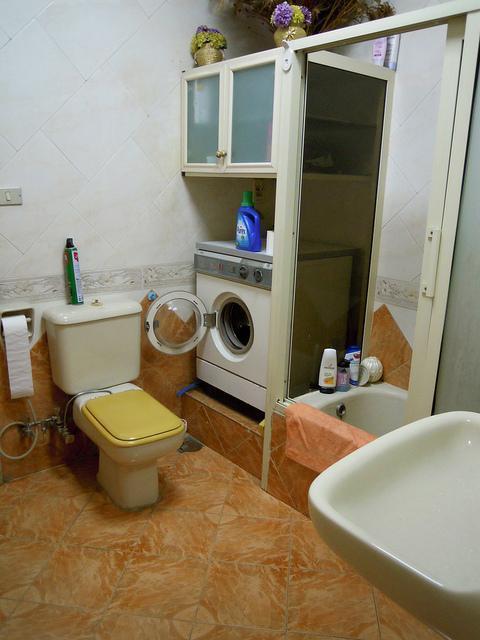How many motorcycles are here?
Give a very brief answer. 0. 